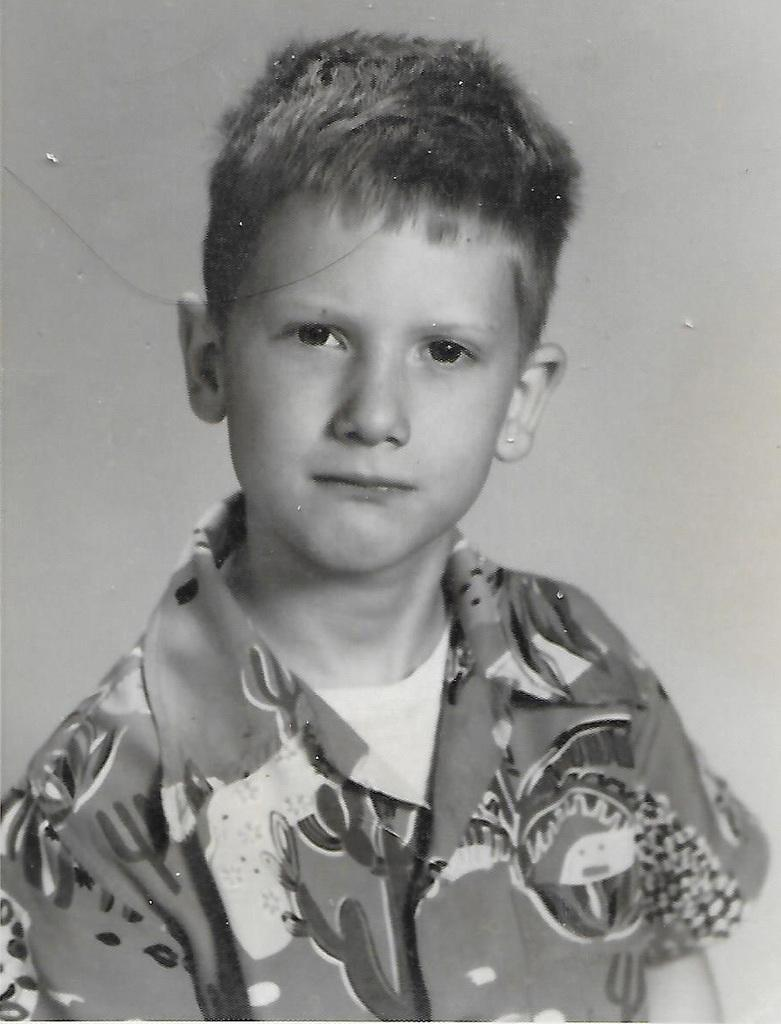What is the color scheme of the image? The image is in black and white. Who is the main subject in the picture? There is a boy in the picture. What is the boy wearing? The boy is wearing a white T-shirt and a shirt. What is the boy doing in the picture? The boy is looking at the camera and might be posing for the photo. What type of nut can be seen on the boy's chin in the image? There is no nut present on the boy's chin in the image. What mathematical division is being performed by the boy in the image? There is no mathematical division being performed by the boy in the image. 